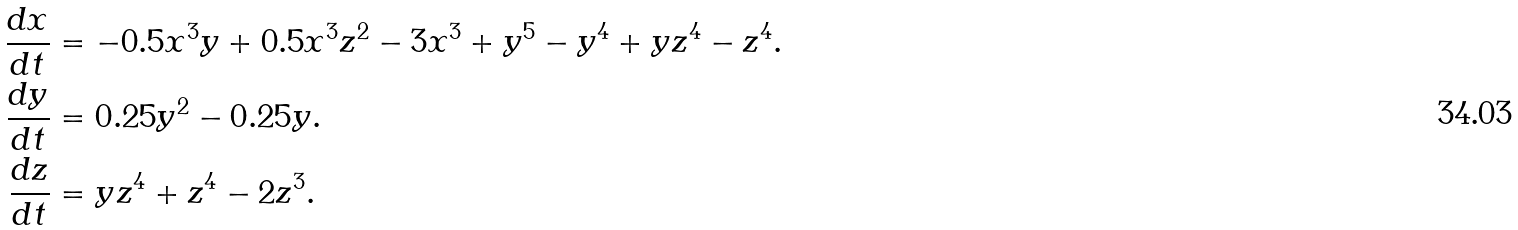Convert formula to latex. <formula><loc_0><loc_0><loc_500><loc_500>\frac { d x } { d t } & = - 0 . 5 x ^ { 3 } y + 0 . 5 x ^ { 3 } z ^ { 2 } - 3 x ^ { 3 } + y ^ { 5 } - y ^ { 4 } + y z ^ { 4 } - z ^ { 4 } . \\ \frac { d y } { d t } & = 0 . 2 5 y ^ { 2 } - 0 . 2 5 y . \\ \frac { d z } { d t } & = y z ^ { 4 } + z ^ { 4 } - 2 z ^ { 3 } . \\</formula> 